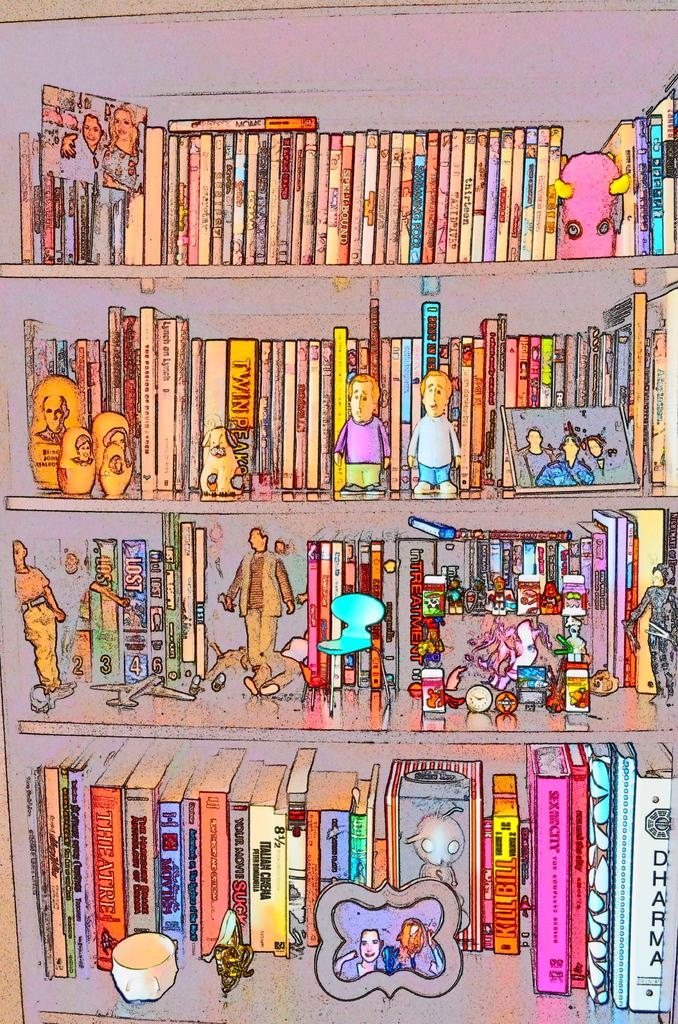<image>
Offer a succinct explanation of the picture presented. A cartoon drawing shows a full bookshelf including a book called, Dharma, and several figurines. 